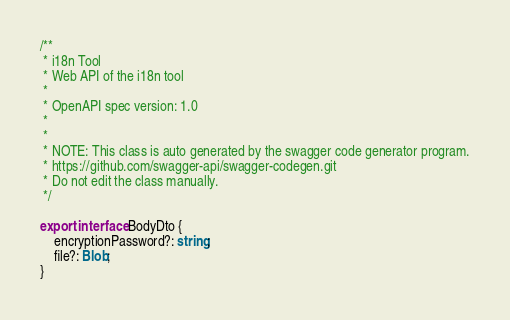Convert code to text. <code><loc_0><loc_0><loc_500><loc_500><_TypeScript_>/**
 * i18n Tool
 * Web API of the i18n tool
 *
 * OpenAPI spec version: 1.0
 * 
 *
 * NOTE: This class is auto generated by the swagger code generator program.
 * https://github.com/swagger-api/swagger-codegen.git
 * Do not edit the class manually.
 */

export interface BodyDto { 
    encryptionPassword?: string;
    file?: Blob;
}</code> 